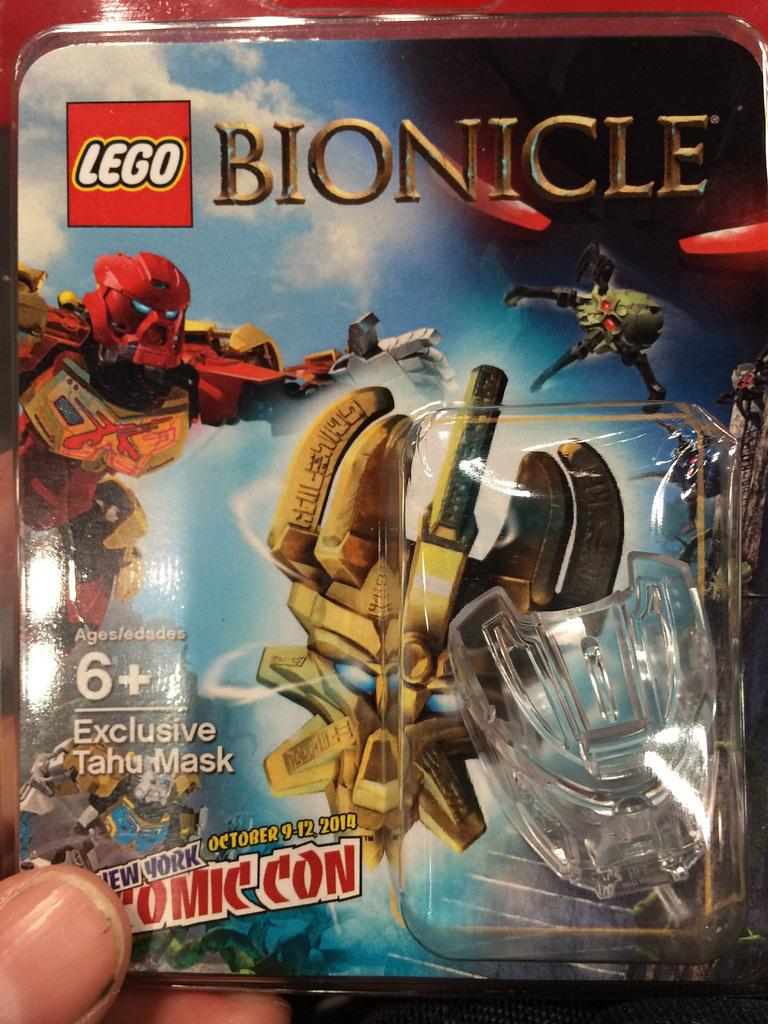What part of the human body is visible in the image? Human fingers are visible in the image. What are the fingers holding? The fingers are holding a sticker. What can be seen in addition to the fingers and sticker? There is text visible in the image. What type of hole can be seen in the image? There is no hole present in the image. Can you describe the straw that is being used by the grandmother in the image? There is no straw or grandmother present in the image. 